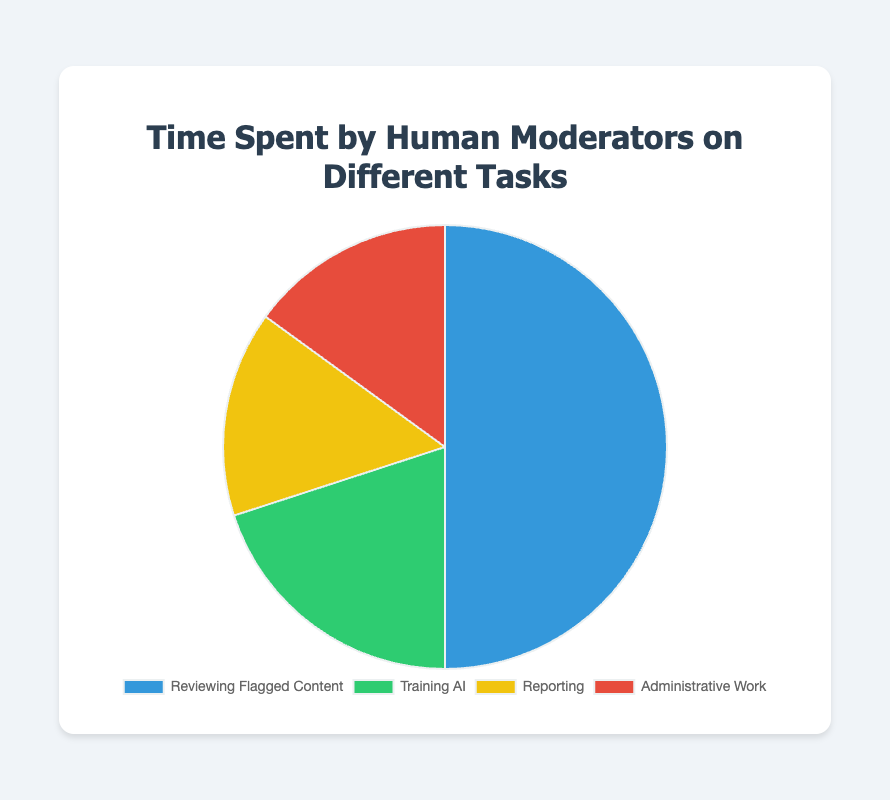What task takes up the most time for human moderators? The pie chart shows that "Reviewing Flagged Content" has the largest slice, representing the highest percentage of time spent.
Answer: Reviewing Flagged Content Which two tasks have equal time allocation? According to the pie chart, the tasks "Reporting" and "Administrative Work" both have equal slices representing the same percentage of time spent.
Answer: Reporting and Administrative Work What percentage of time is spent on non-reviewing tasks? Adding the percentages for "Training AI," "Reporting," and "Administrative Work" gives us the total time spent on non-reviewing tasks. That's 20% + 15% + 15% = 50%.
Answer: 50% How much more time is spent on "Reviewing Flagged Content" compared to "Training AI"? The pie chart indicates that "Reviewing Flagged Content" takes 50% of the time, while "Training AI" takes 20%. The difference between these percentages is 50% - 20% = 30%.
Answer: 30% What proportion of time is spent on "Reporting" relative to the total time spent on "Administrative Work"? Both "Reporting" and "Administrative Work" each account for 15% of the time. The ratio between them is 15:15, which simplifies to 1:1.
Answer: 1:1 If 5 hours are spent each day on these tasks, how much time is spent on "Training AI"? To find this, we calculate 20% of 5 hours. 0.20 * 5 = 1 hour.
Answer: 1 hour How does the proportion of time spent on "Administrative Work" compare to "Training AI"? The pie chart shows that both tasks take up 20% and 15% of the time, respectively. Therefore, "Training AI" takes up more time: 20% vs. 15%.
Answer: Training AI takes up more time What is the total time spent on "Reporting" and "Administrative Work" combined? Adding the percentages for "Reporting" and "Administrative Work," we get 15% + 15% = 30%.
Answer: 30% What task is represented by the green color on the pie chart? The description mentioned that "Training AI" is represented by the green section of the pie chart.
Answer: Training AI 